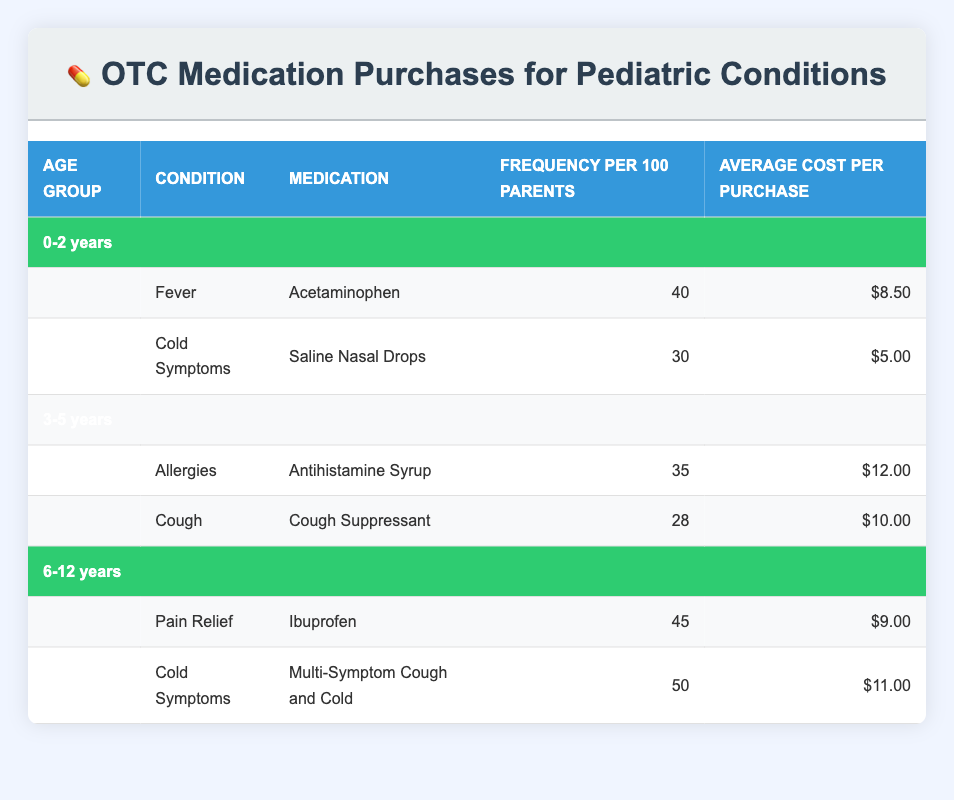What is the frequency of parents purchasing Acetaminophen for a child aged 0-2 years? The table indicates that 40 out of 100 parents purchase Acetaminophen for fever in children aged 0-2 years.
Answer: 40 Which medication is most frequently purchased by parents for cold symptoms in children aged 6-12 years? The table shows that 50 out of 100 parents purchase Multi-Symptom Cough and Cold for cold symptoms in children aged 6-12 years, which is higher than any other medication for this condition across all age groups.
Answer: Multi-Symptom Cough and Cold Is the average cost of Antihistamine Syrup greater than $10.00? The table indicates that the average cost per purchase of Antihistamine Syrup is $12.00, which is greater than $10.00, thus the statement is true.
Answer: Yes What is the total frequency of OTC medication purchases for cold symptoms across all age groups? For children aged 0-2 years, the frequency is 30 for saline nasal drops, and for ages 6-12 years, it is 50 for Multi-Symptom Cough and Cold. Adding these together gives (30 + 50 = 80) indicating that 80 out of 100 parents purchase these medications for cold symptoms across the age groups considered.
Answer: 80 Which age group has the highest frequency of purchasing OTC medications for pain relief? The table shows that only the 6-12 years age group has a specific entry for pain relief with a frequency of 45, while no other age groups report pain relief purchases. Therefore, this age group has the highest frequency for pain relief.
Answer: 6-12 years How much more does the average cost of medication for allergies in children aged 3-5 years compare to the average cost of medication for fever in children aged 0-2 years? The average cost of Antihistamine Syrup for allergies is $12.00 and for Acetaminophen for fever it is $8.50. To find the difference, we perform the calculation: $12.00 - $8.50 = $3.50, indicating that the average cost for allergies is $3.50 more.
Answer: $3.50 Is it true that less than 30% of parents purchase cough suppressants for children aged 3-5 years? The frequency of parents purchasing cough suppressants for children aged 3-5 years is 28 out of 100, which translates to 28%. Thus, the statement that this is less than 30% is true.
Answer: Yes What is the average cost of OTC medications for cold symptoms across all listed age groups? The cost of medications for cold symptoms is $5.00 for saline nasal drops and $11.00 for Multi-Symptom Cough and Cold. Summing these costs gives $5.00 + $11.00 = $16.00. There are two entries, so the average cost is $16.00 / 2 = $8.00.
Answer: $8.00 